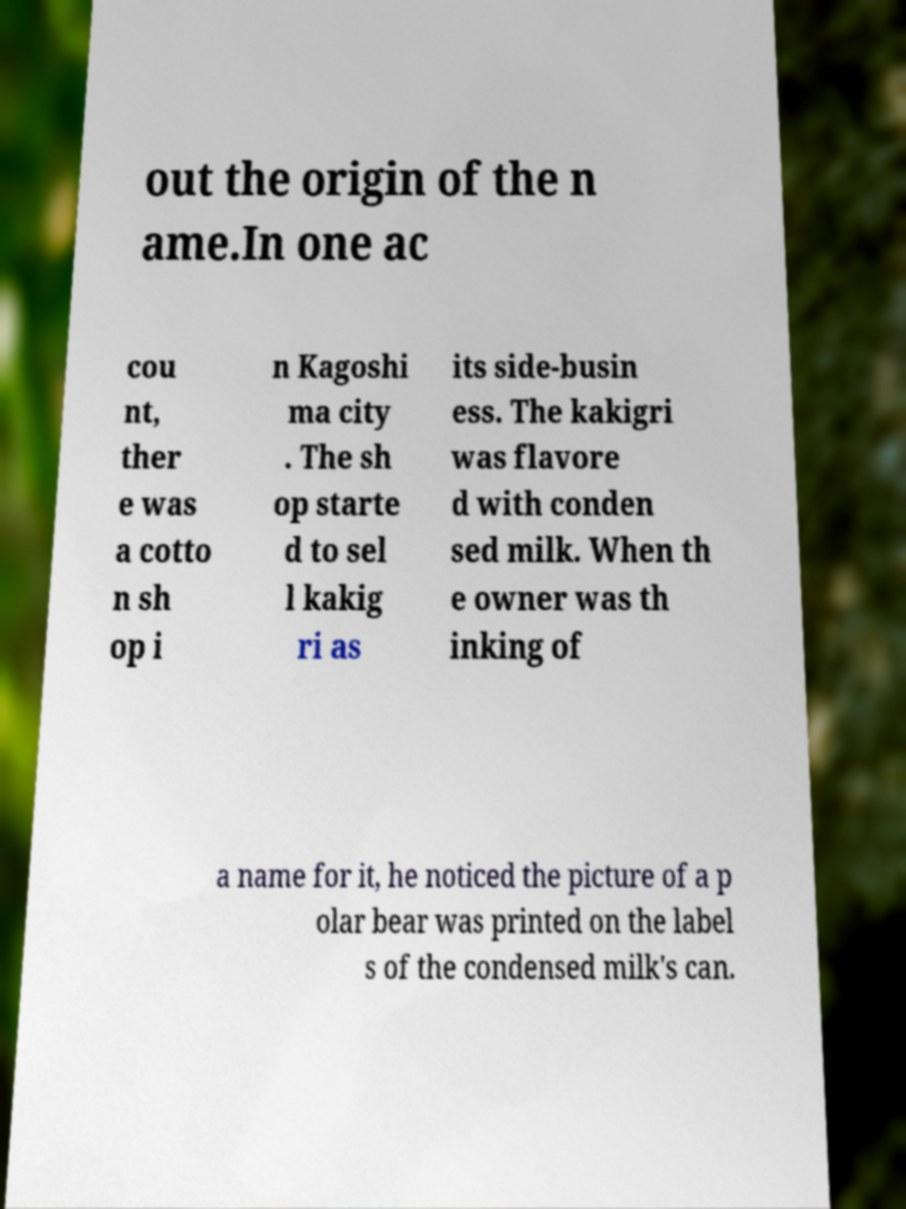For documentation purposes, I need the text within this image transcribed. Could you provide that? out the origin of the n ame.In one ac cou nt, ther e was a cotto n sh op i n Kagoshi ma city . The sh op starte d to sel l kakig ri as its side-busin ess. The kakigri was flavore d with conden sed milk. When th e owner was th inking of a name for it, he noticed the picture of a p olar bear was printed on the label s of the condensed milk's can. 